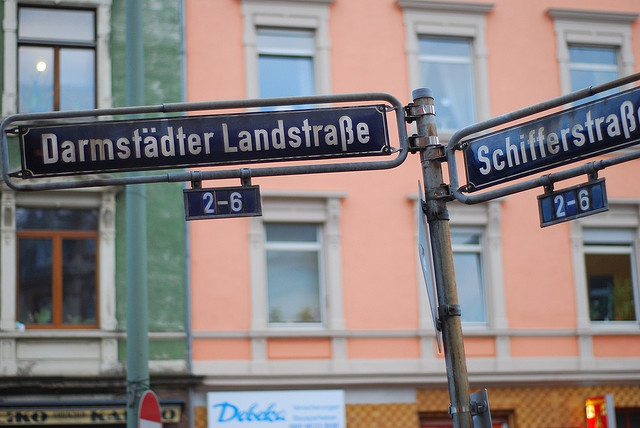Describe the objects in this image and their specific colors. I can see various objects in this image with different colors. 